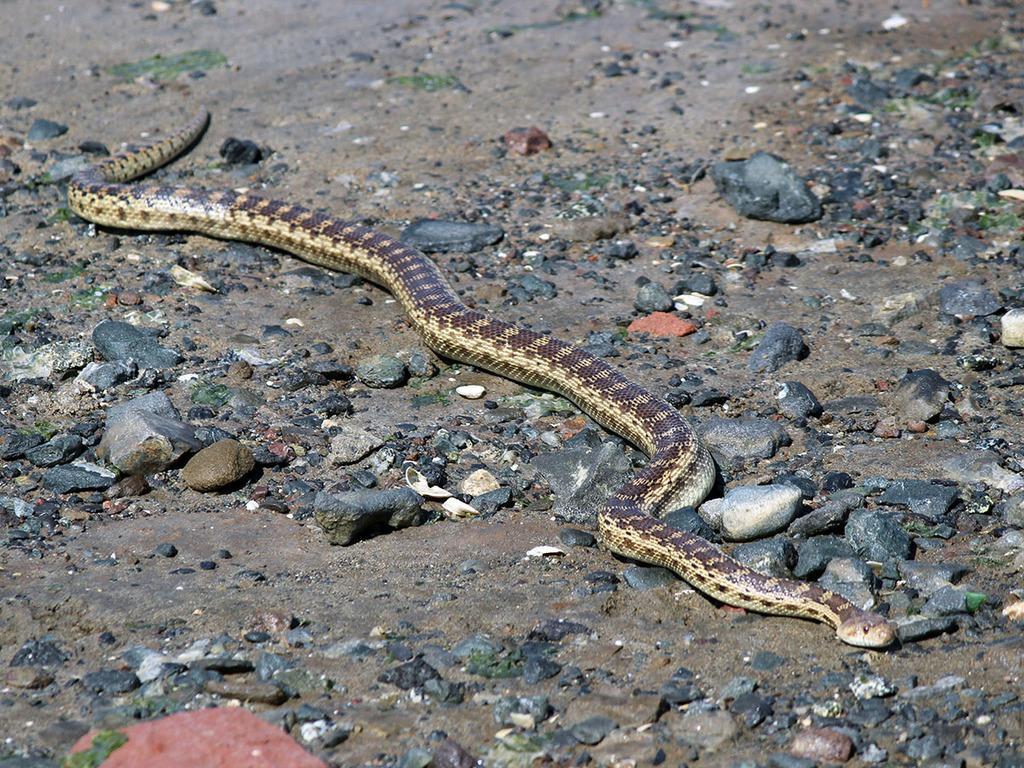Please provide a concise description of this image. In this image I can see the ground and on the ground I can see few stones and a snake which is cream and brown in color. 